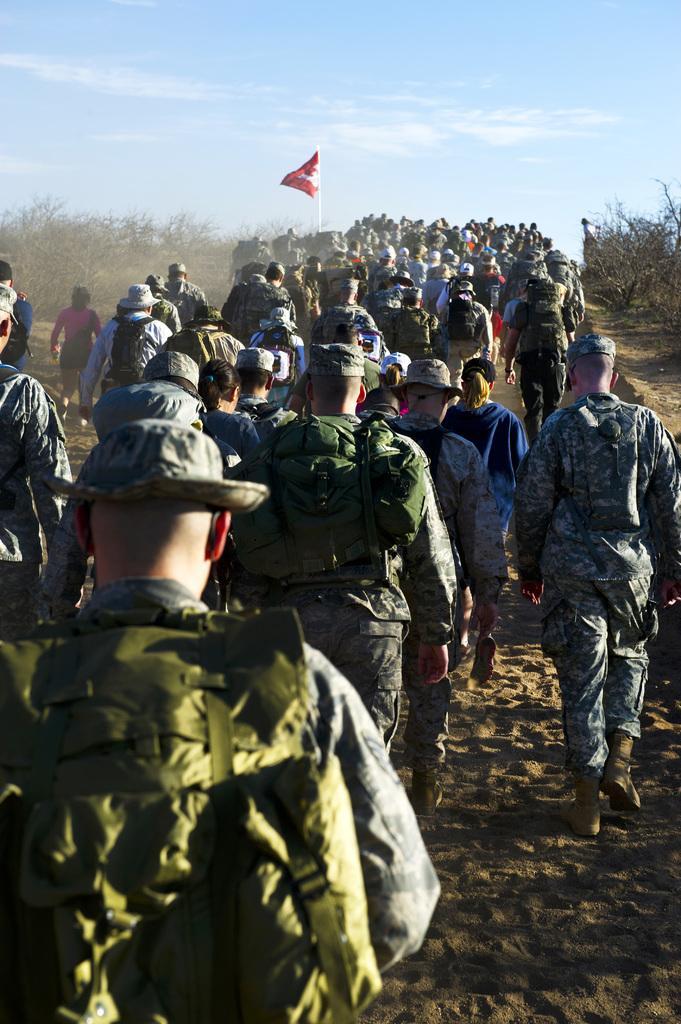Describe this image in one or two sentences. In this image we can see army people are walking on the road. Background of the image one flag is there and dry plants are available. 